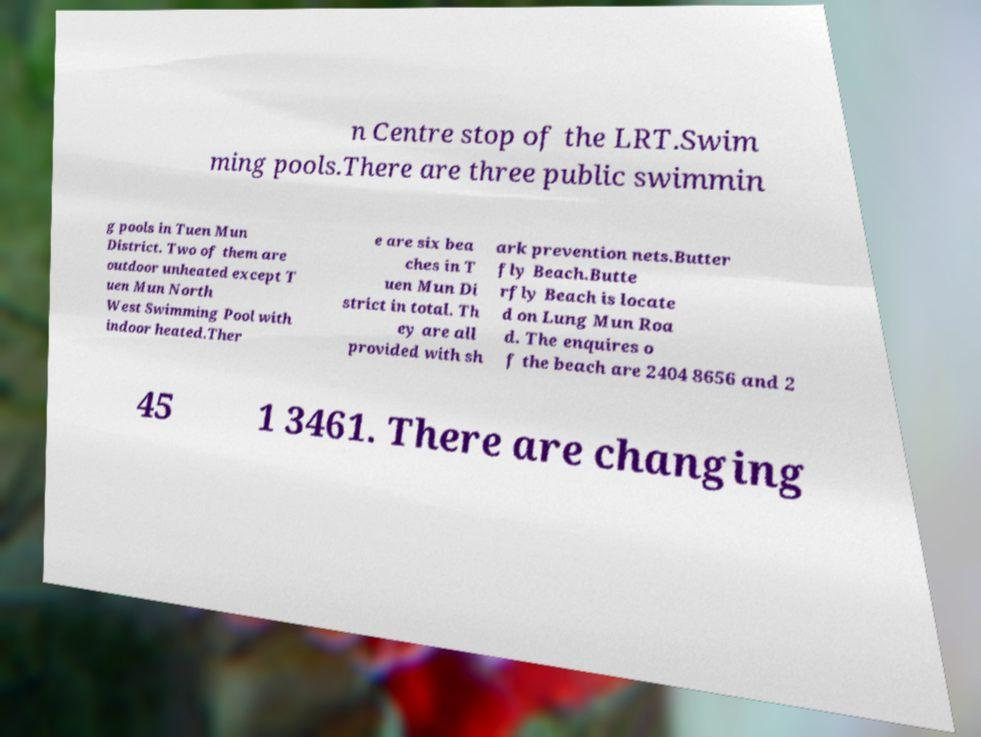For documentation purposes, I need the text within this image transcribed. Could you provide that? n Centre stop of the LRT.Swim ming pools.There are three public swimmin g pools in Tuen Mun District. Two of them are outdoor unheated except T uen Mun North West Swimming Pool with indoor heated.Ther e are six bea ches in T uen Mun Di strict in total. Th ey are all provided with sh ark prevention nets.Butter fly Beach.Butte rfly Beach is locate d on Lung Mun Roa d. The enquires o f the beach are 2404 8656 and 2 45 1 3461. There are changing 